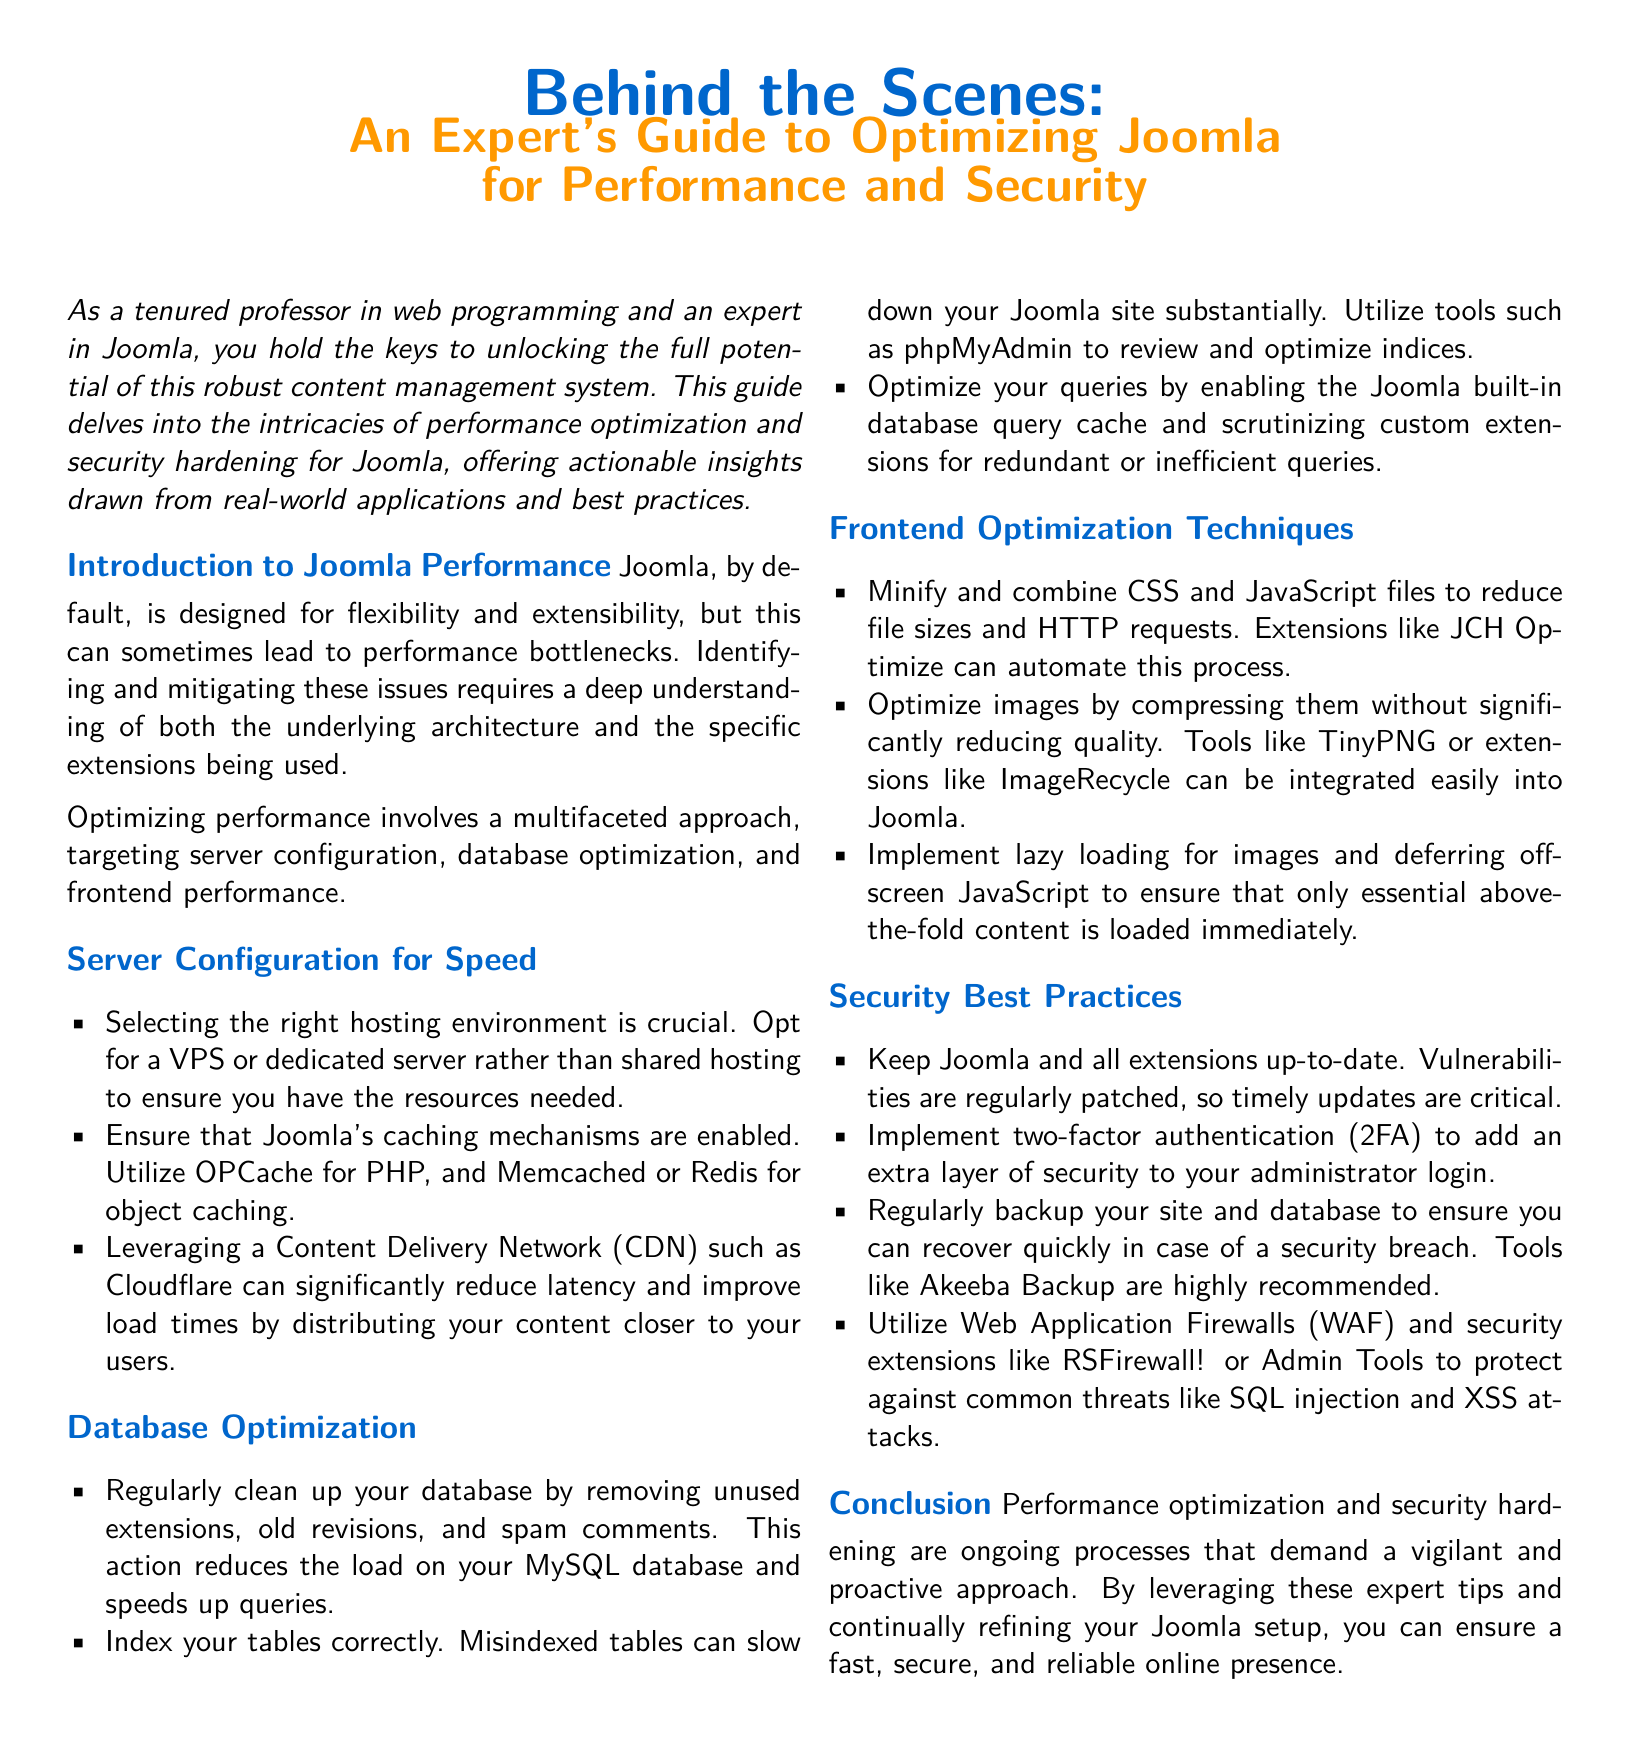What is the main color used in the document? The main color used in the document is defined by the RGB values specified for maincolor, which is (0, 102, 204).
Answer: blue What is the second color used in the title? The second color used in the title is defined by the RGB values specified for secondcolor, which is (255, 153, 0).
Answer: orange What is the first section title in the document? The first section title is found at the beginning of the content, after the introduction, which is "Introduction to Joomla Performance."
Answer: Introduction to Joomla Performance Which optimization technique involves compressing images? The document lists various frontend optimization techniques, one of which is optimizing images by compressing them.
Answer: Optimize images What security measure is recommended for administrator login? The document suggests implementing two-factor authentication to enhance security for administrator login.
Answer: Two-factor authentication How many main topics are covered in the document? The main topics are the sections outlined in the document, which include performance optimization and security best practices. There are five main sections.
Answer: Five What type of server is recommended for Joomla hosting? The document advises selecting a VPS or dedicated server to ensure adequate resources for Joomla.
Answer: VPS or dedicated server What tool is suggested for regular backups of the site? The document recommends using Akeeba Backup as a tool for regular backups of the Joomla site.
Answer: Akeeba Backup 